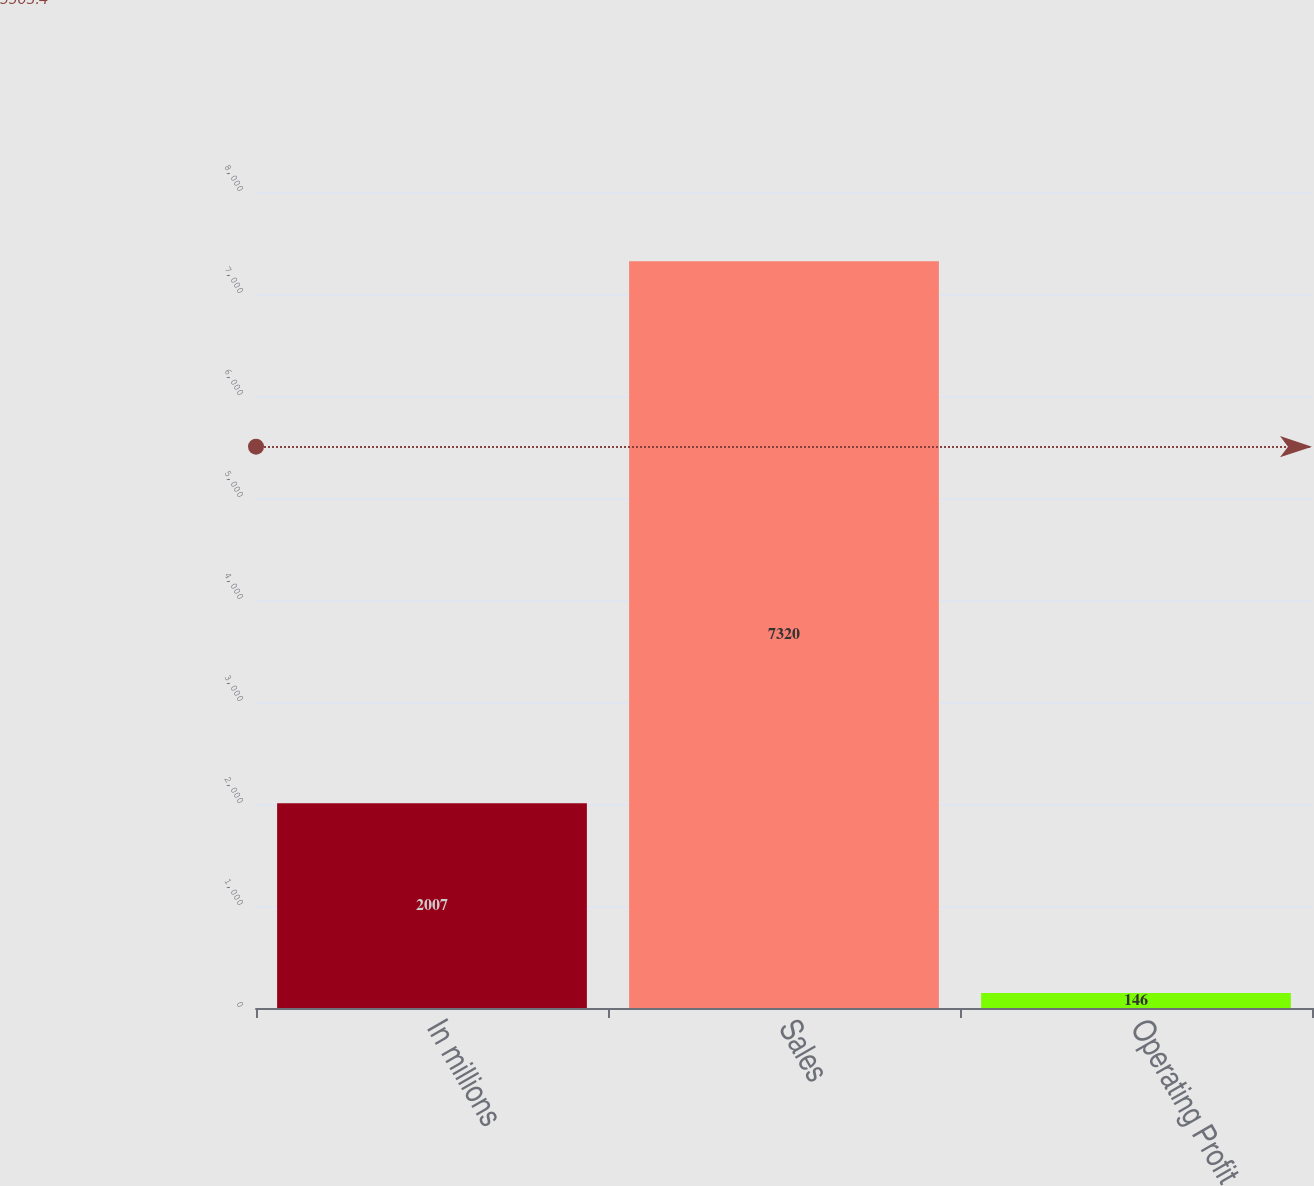Convert chart to OTSL. <chart><loc_0><loc_0><loc_500><loc_500><bar_chart><fcel>In millions<fcel>Sales<fcel>Operating Profit<nl><fcel>2007<fcel>7320<fcel>146<nl></chart> 